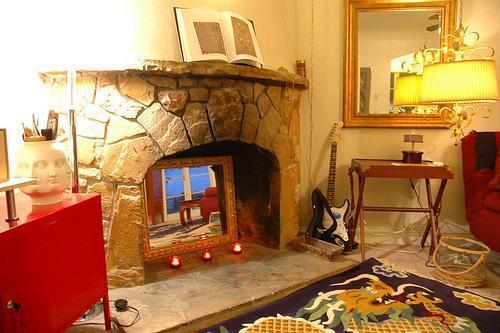How many candles are inside the fireplace?
Give a very brief answer. 3. 